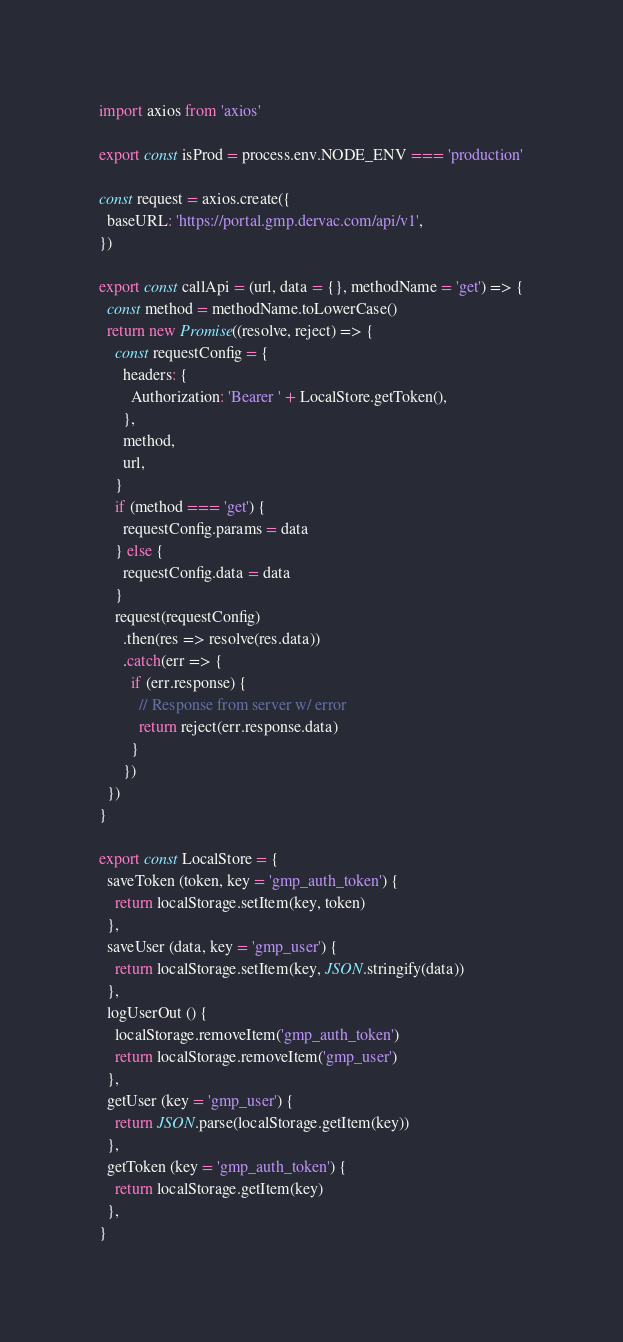Convert code to text. <code><loc_0><loc_0><loc_500><loc_500><_JavaScript_>import axios from 'axios'

export const isProd = process.env.NODE_ENV === 'production'

const request = axios.create({
  baseURL: 'https://portal.gmp.dervac.com/api/v1',
})

export const callApi = (url, data = {}, methodName = 'get') => {
  const method = methodName.toLowerCase()
  return new Promise((resolve, reject) => {
    const requestConfig = {
      headers: {
        Authorization: 'Bearer ' + LocalStore.getToken(),
      },
      method,
      url,
    }
    if (method === 'get') {
      requestConfig.params = data
    } else {
      requestConfig.data = data
    }
    request(requestConfig)
      .then(res => resolve(res.data))
      .catch(err => {
        if (err.response) {
          // Response from server w/ error
          return reject(err.response.data)
        }
      })
  })
}

export const LocalStore = {
  saveToken (token, key = 'gmp_auth_token') {
    return localStorage.setItem(key, token)
  },
  saveUser (data, key = 'gmp_user') {
    return localStorage.setItem(key, JSON.stringify(data))
  },
  logUserOut () {
    localStorage.removeItem('gmp_auth_token')
    return localStorage.removeItem('gmp_user')
  },
  getUser (key = 'gmp_user') {
    return JSON.parse(localStorage.getItem(key))
  },
  getToken (key = 'gmp_auth_token') {
    return localStorage.getItem(key)
  },
}
</code> 